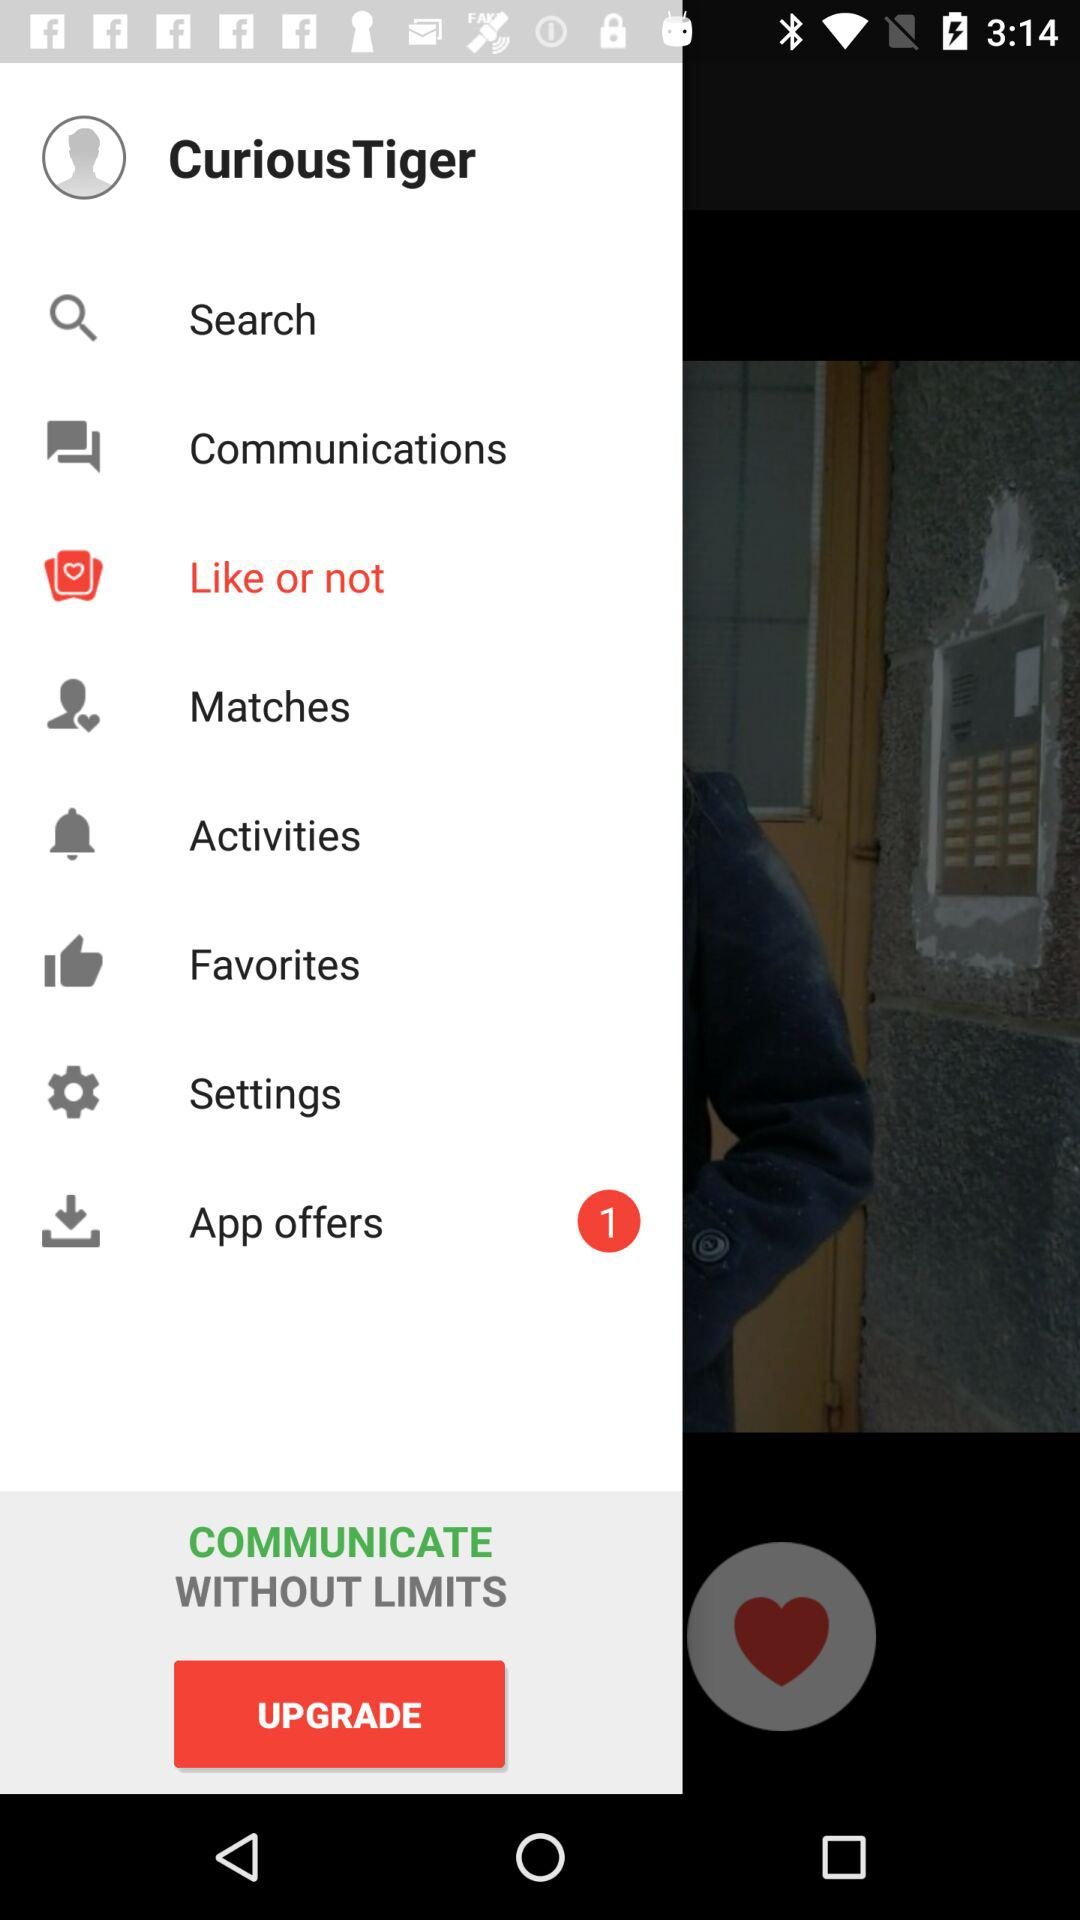What is the name of the application?
When the provided information is insufficient, respond with <no answer>. <no answer> 